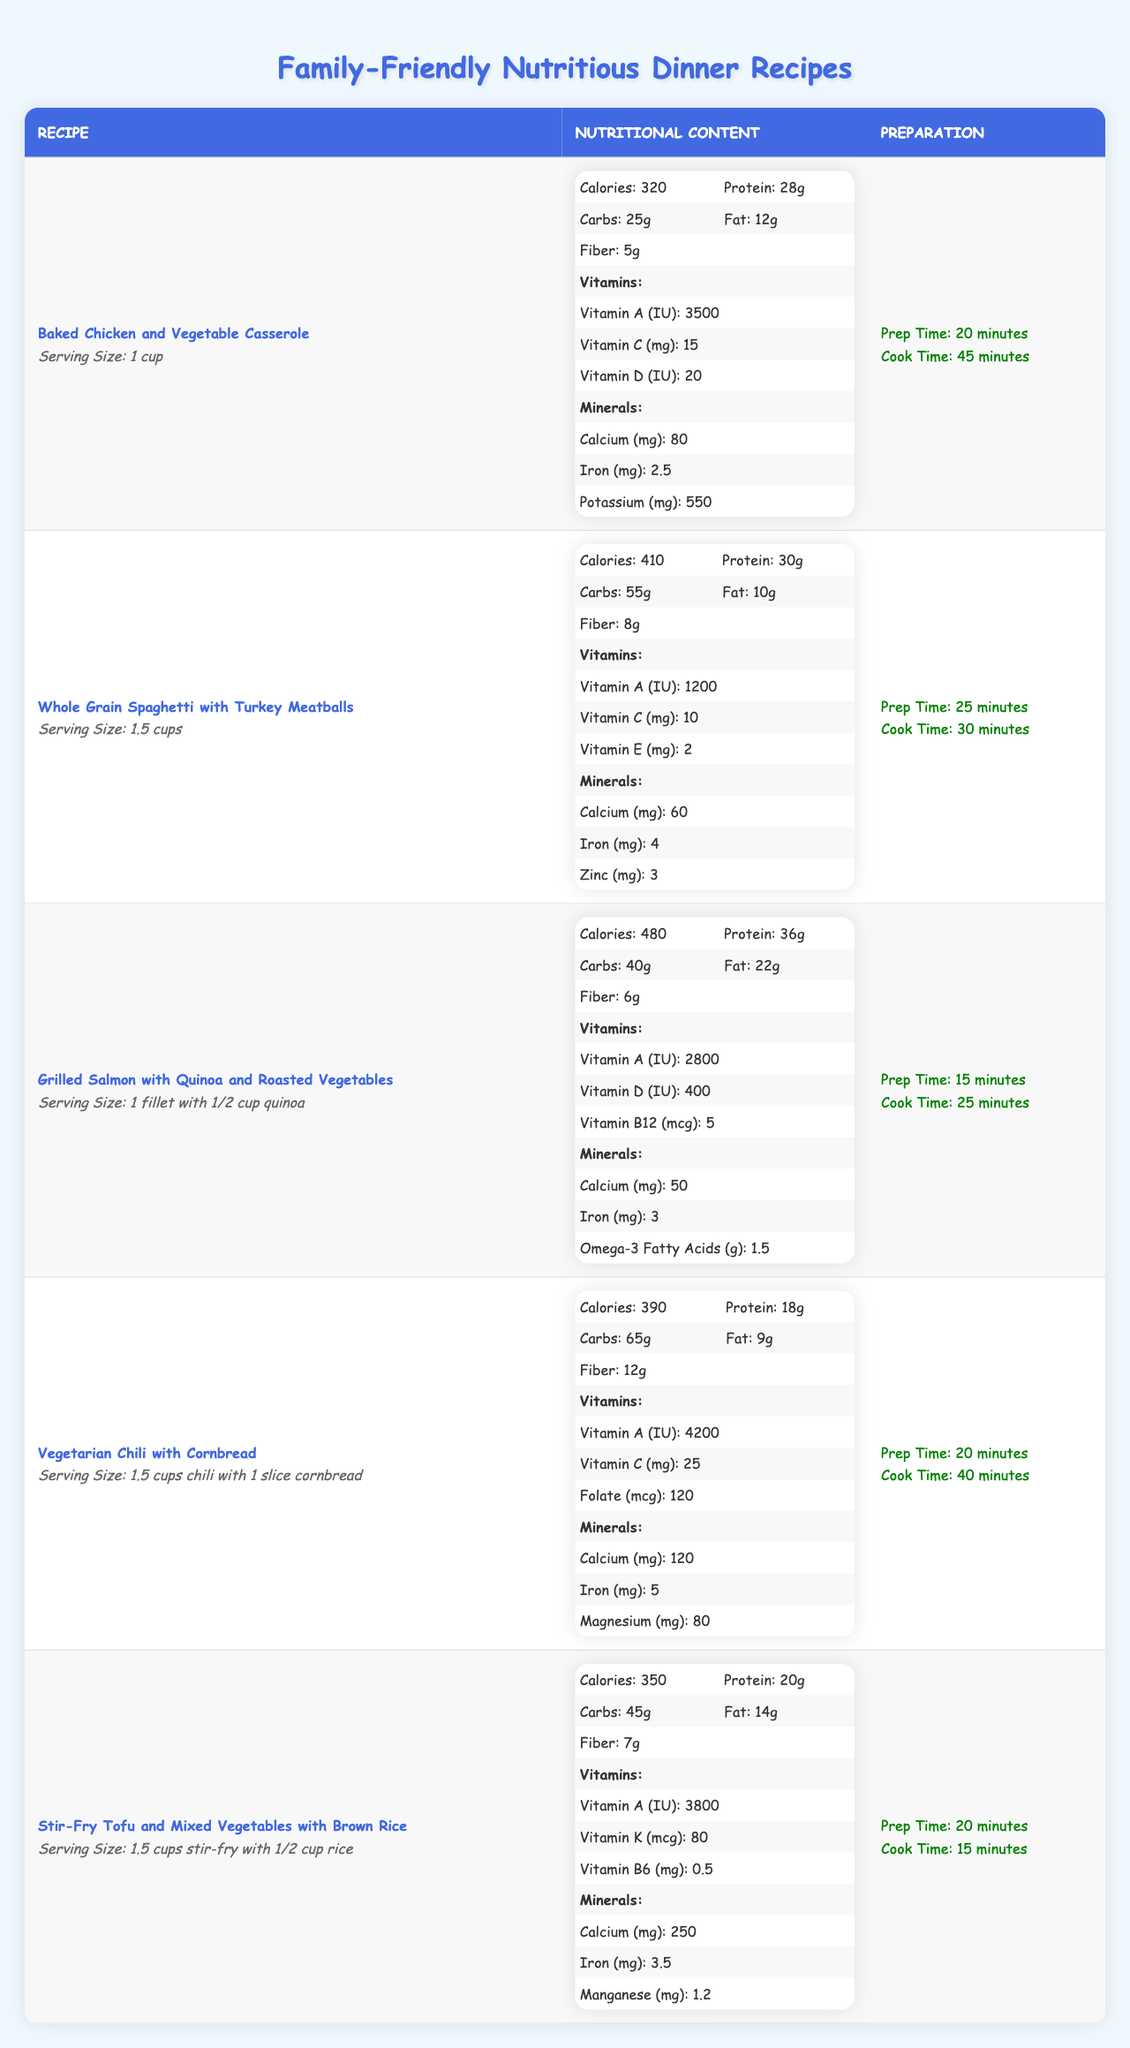What is the total cooking time for "Vegetarian Chili with Cornbread"? The cooking time for "Vegetarian Chili with Cornbread" is 40 minutes, and the prep time is 20 minutes. Therefore, the total cooking time is 40 + 20 = 60 minutes.
Answer: 60 minutes Which recipe has the highest protein content? By examining the nutritional content of all recipes, "Grilled Salmon with Quinoa and Roasted Vegetables" has the highest protein content at 36 grams.
Answer: Grilled Salmon with Quinoa and Roasted Vegetables How many grams of carbohydrates are in "Whole Grain Spaghetti with Turkey Meatballs"? The recipe for "Whole Grain Spaghetti with Turkey Meatballs" indicates there are 55 grams of carbohydrates in a serving.
Answer: 55 grams What is the average amount of fiber across all recipes? To find the average fiber, we sum the fiber values: 5 + 8 + 6 + 12 + 7 = 38 grams. There are 5 recipes, so the average is 38 / 5 = 7.6 grams.
Answer: 7.6 grams Does "Baked Chicken and Vegetable Casserole" contain more calories than "Stir-Fry Tofu and Mixed Vegetables"? "Baked Chicken and Vegetable Casserole" has 320 calories while "Stir-Fry Tofu and Mixed Vegetables" has 350 calories. Since 320 is less than 350, this statement is false.
Answer: No What is the serving size for "Grilled Salmon with Quinoa and Roasted Vegetables"? The serving size for "Grilled Salmon with Quinoa and Roasted Vegetables" is specified as 1 fillet with 1/2 cup quinoa.
Answer: 1 fillet with 1/2 cup quinoa Which recipe has the lowest fat content? By comparing the fat contents, "Whole Grain Spaghetti with Turkey Meatballs" has the lowest fat content, at 10 grams.
Answer: Whole Grain Spaghetti with Turkey Meatballs What is the total vitamin A content across all recipes? The vitamin A content for each recipe is 3500 + 1200 + 2800 + 4200 + 3800 = 15500 IU. This total shows the combined vitamin A in all recipes.
Answer: 15500 IU How much calcium does "Vegetarian Chili with Cornbread" provide? The nutritional data indicates that "Vegetarian Chili with Cornbread" provides 120 mg of calcium per serving.
Answer: 120 mg Is the fiber content of "Stir-Fry Tofu and Mixed Vegetables" above the average fiber content? The fiber content of "Stir-Fry Tofu and Mixed Vegetables" is 7 grams, and the average fiber across recipes is 7.6 grams. Since 7 is less than 7.6, the statement is false.
Answer: No 